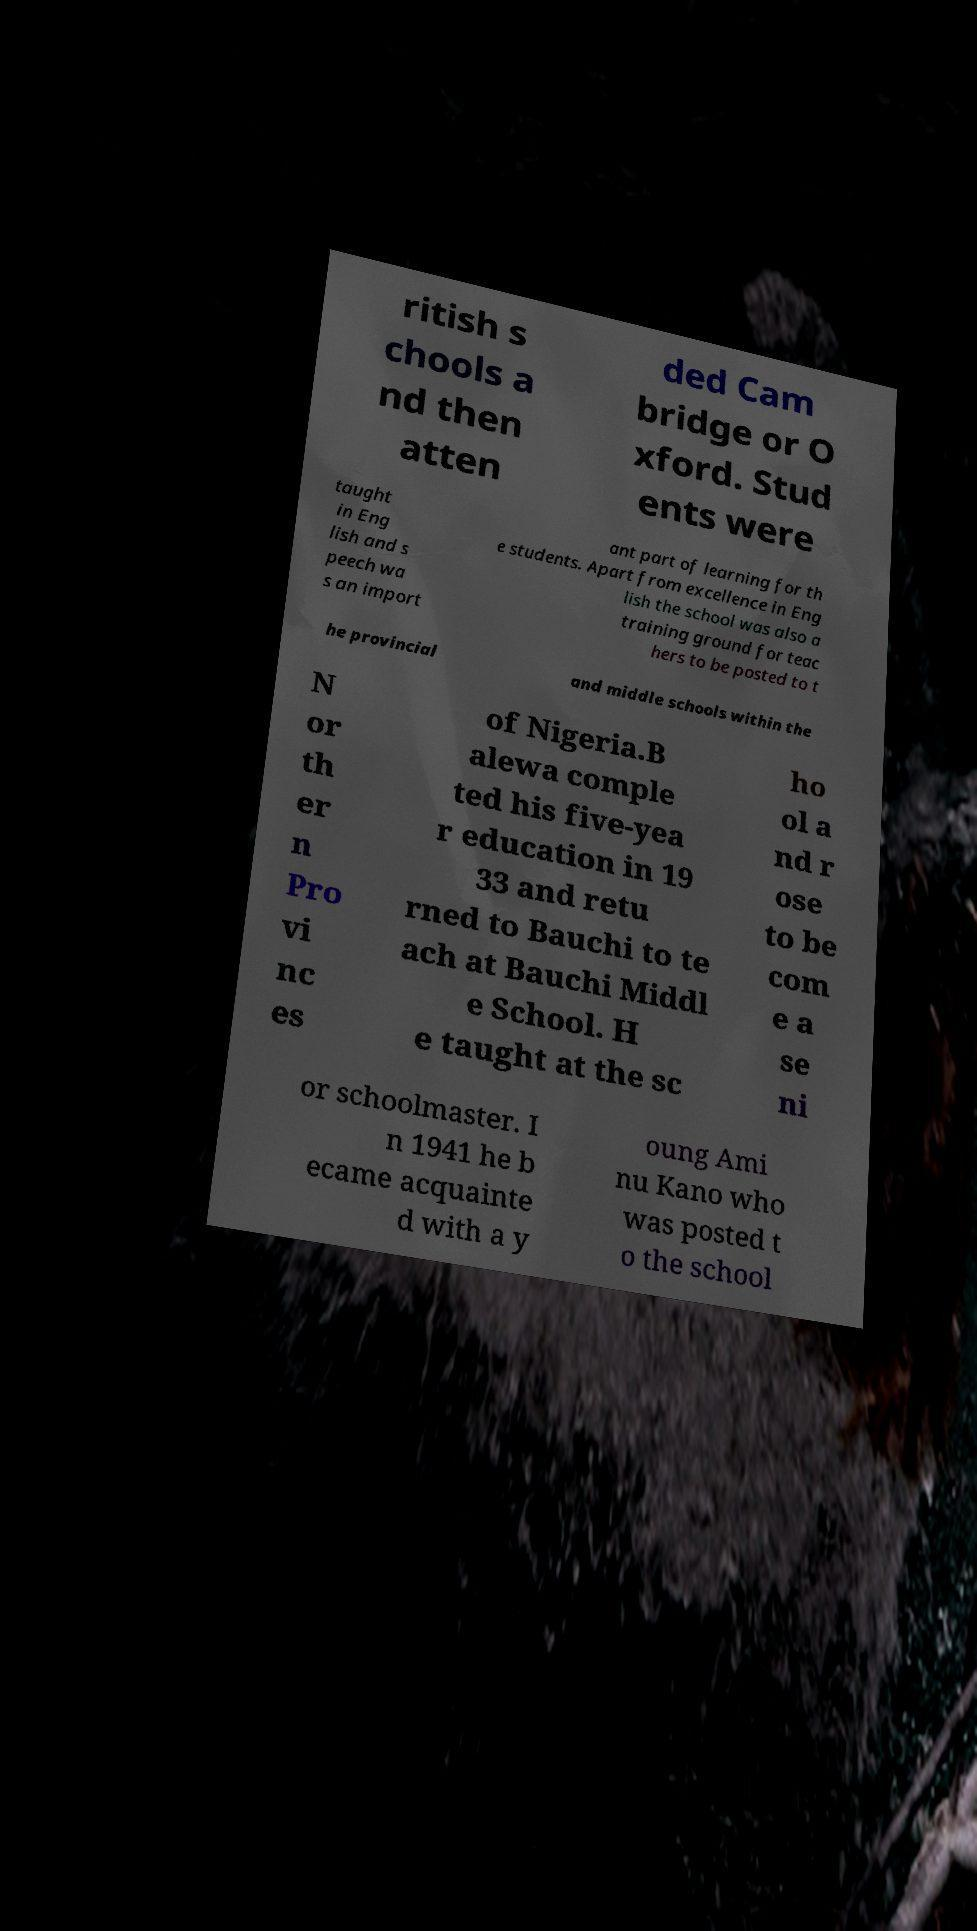Please read and relay the text visible in this image. What does it say? ritish s chools a nd then atten ded Cam bridge or O xford. Stud ents were taught in Eng lish and s peech wa s an import ant part of learning for th e students. Apart from excellence in Eng lish the school was also a training ground for teac hers to be posted to t he provincial and middle schools within the N or th er n Pro vi nc es of Nigeria.B alewa comple ted his five-yea r education in 19 33 and retu rned to Bauchi to te ach at Bauchi Middl e School. H e taught at the sc ho ol a nd r ose to be com e a se ni or schoolmaster. I n 1941 he b ecame acquainte d with a y oung Ami nu Kano who was posted t o the school 